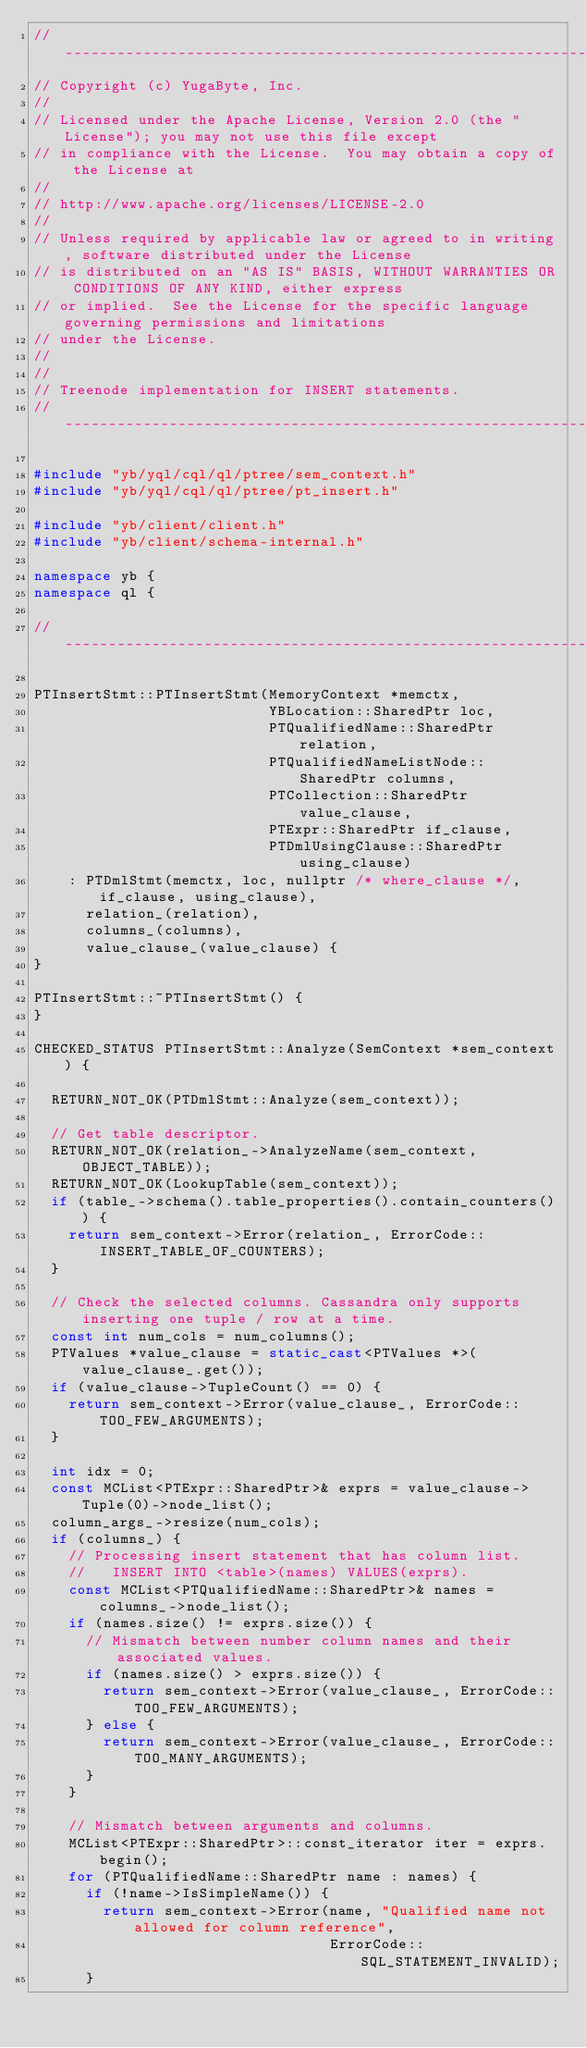<code> <loc_0><loc_0><loc_500><loc_500><_C++_>//--------------------------------------------------------------------------------------------------
// Copyright (c) YugaByte, Inc.
//
// Licensed under the Apache License, Version 2.0 (the "License"); you may not use this file except
// in compliance with the License.  You may obtain a copy of the License at
//
// http://www.apache.org/licenses/LICENSE-2.0
//
// Unless required by applicable law or agreed to in writing, software distributed under the License
// is distributed on an "AS IS" BASIS, WITHOUT WARRANTIES OR CONDITIONS OF ANY KIND, either express
// or implied.  See the License for the specific language governing permissions and limitations
// under the License.
//
//
// Treenode implementation for INSERT statements.
//--------------------------------------------------------------------------------------------------

#include "yb/yql/cql/ql/ptree/sem_context.h"
#include "yb/yql/cql/ql/ptree/pt_insert.h"

#include "yb/client/client.h"
#include "yb/client/schema-internal.h"

namespace yb {
namespace ql {

//--------------------------------------------------------------------------------------------------

PTInsertStmt::PTInsertStmt(MemoryContext *memctx,
                           YBLocation::SharedPtr loc,
                           PTQualifiedName::SharedPtr relation,
                           PTQualifiedNameListNode::SharedPtr columns,
                           PTCollection::SharedPtr value_clause,
                           PTExpr::SharedPtr if_clause,
                           PTDmlUsingClause::SharedPtr using_clause)
    : PTDmlStmt(memctx, loc, nullptr /* where_clause */, if_clause, using_clause),
      relation_(relation),
      columns_(columns),
      value_clause_(value_clause) {
}

PTInsertStmt::~PTInsertStmt() {
}

CHECKED_STATUS PTInsertStmt::Analyze(SemContext *sem_context) {

  RETURN_NOT_OK(PTDmlStmt::Analyze(sem_context));

  // Get table descriptor.
  RETURN_NOT_OK(relation_->AnalyzeName(sem_context, OBJECT_TABLE));
  RETURN_NOT_OK(LookupTable(sem_context));
  if (table_->schema().table_properties().contain_counters()) {
    return sem_context->Error(relation_, ErrorCode::INSERT_TABLE_OF_COUNTERS);
  }

  // Check the selected columns. Cassandra only supports inserting one tuple / row at a time.
  const int num_cols = num_columns();
  PTValues *value_clause = static_cast<PTValues *>(value_clause_.get());
  if (value_clause->TupleCount() == 0) {
    return sem_context->Error(value_clause_, ErrorCode::TOO_FEW_ARGUMENTS);
  }

  int idx = 0;
  const MCList<PTExpr::SharedPtr>& exprs = value_clause->Tuple(0)->node_list();
  column_args_->resize(num_cols);
  if (columns_) {
    // Processing insert statement that has column list.
    //   INSERT INTO <table>(names) VALUES(exprs).
    const MCList<PTQualifiedName::SharedPtr>& names = columns_->node_list();
    if (names.size() != exprs.size()) {
      // Mismatch between number column names and their associated values.
      if (names.size() > exprs.size()) {
        return sem_context->Error(value_clause_, ErrorCode::TOO_FEW_ARGUMENTS);
      } else {
        return sem_context->Error(value_clause_, ErrorCode::TOO_MANY_ARGUMENTS);
      }
    }

    // Mismatch between arguments and columns.
    MCList<PTExpr::SharedPtr>::const_iterator iter = exprs.begin();
    for (PTQualifiedName::SharedPtr name : names) {
      if (!name->IsSimpleName()) {
        return sem_context->Error(name, "Qualified name not allowed for column reference",
                                  ErrorCode::SQL_STATEMENT_INVALID);
      }</code> 